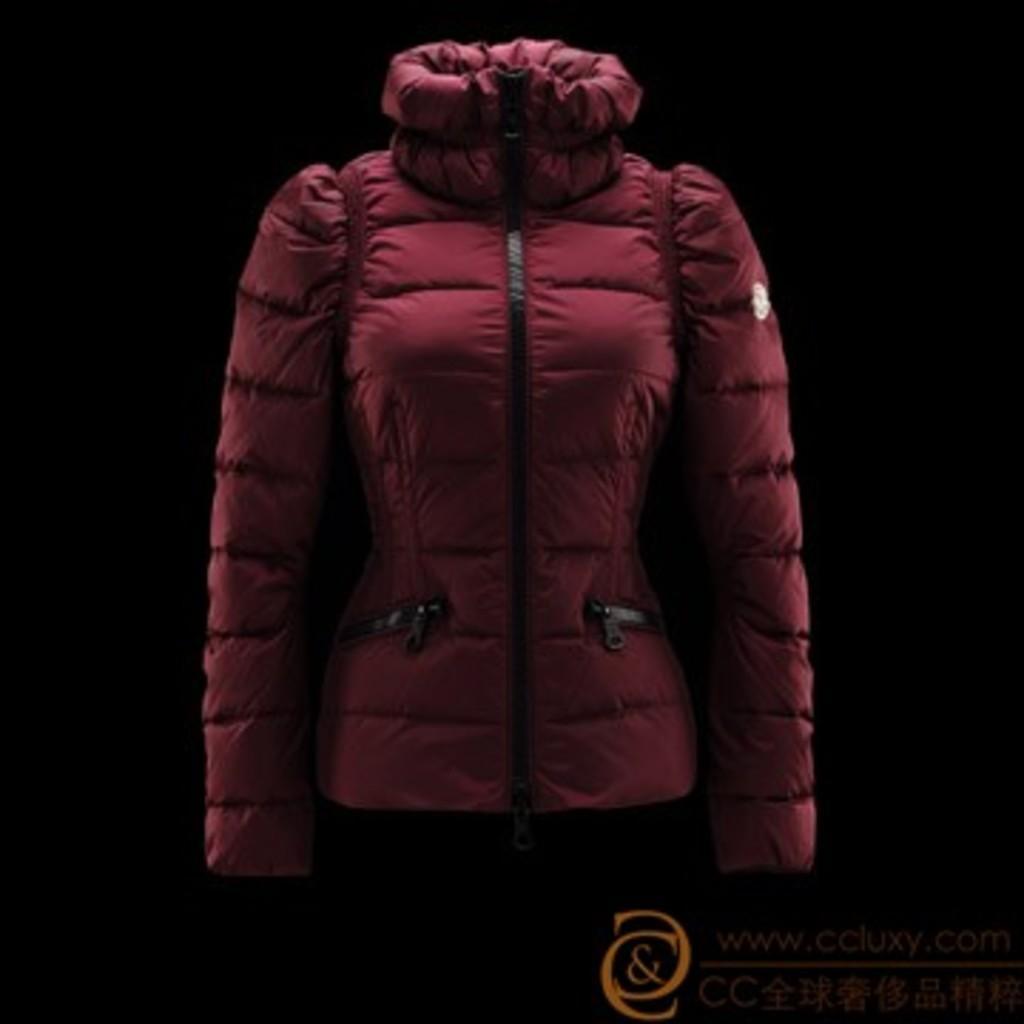How would you summarize this image in a sentence or two? In this picture we can observe a maroon color jacket. There is an orange color watermark on the right side. The background is completely dark. 